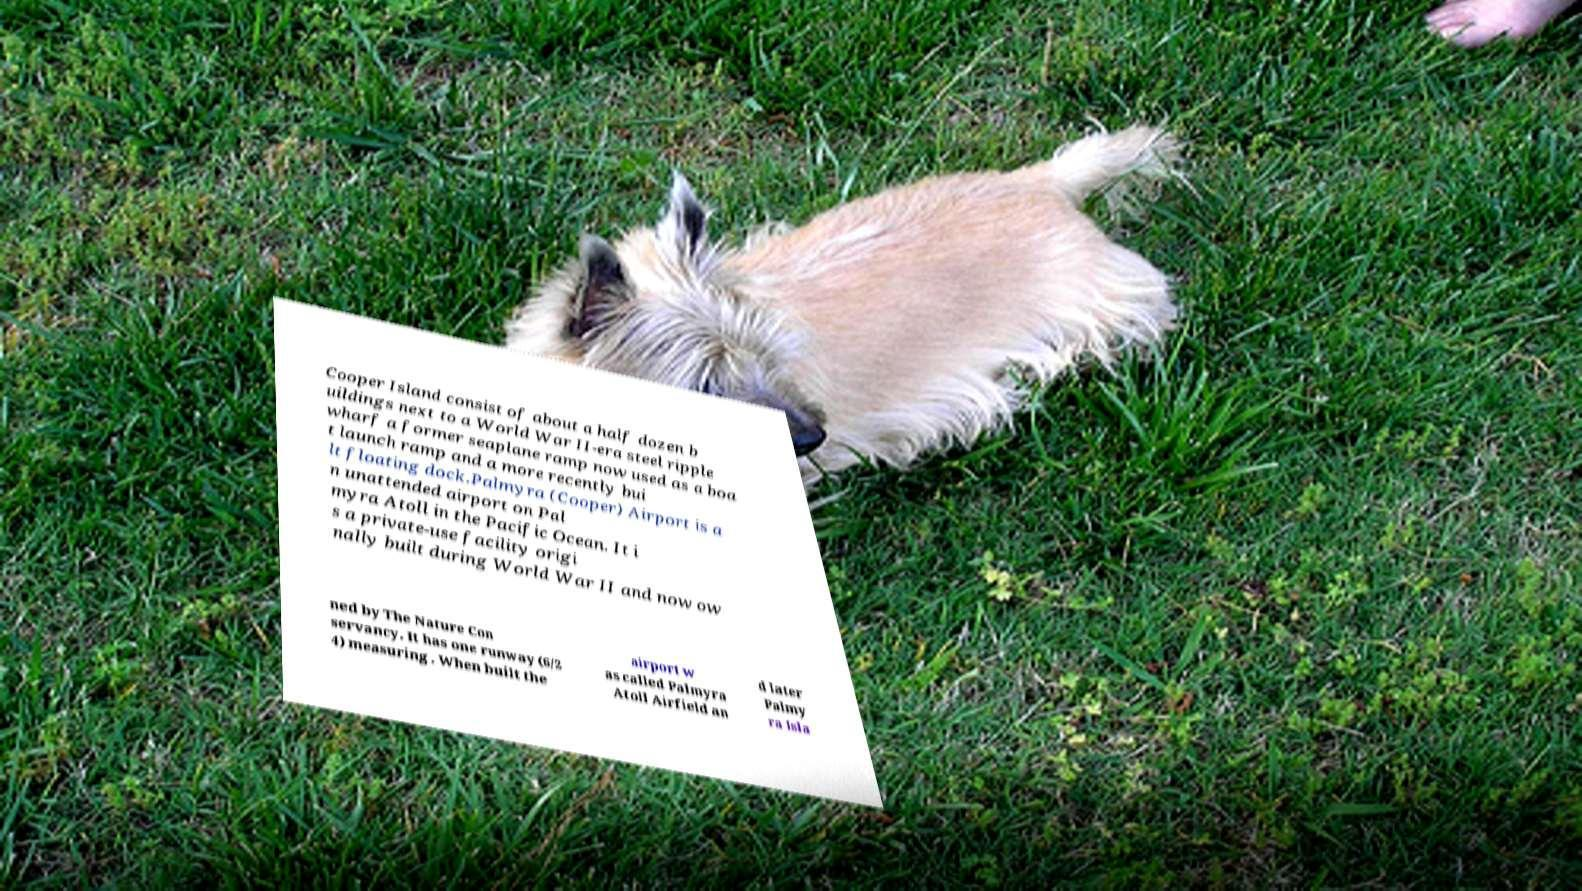Please read and relay the text visible in this image. What does it say? Cooper Island consist of about a half dozen b uildings next to a World War II-era steel ripple wharf a former seaplane ramp now used as a boa t launch ramp and a more recently bui lt floating dock.Palmyra (Cooper) Airport is a n unattended airport on Pal myra Atoll in the Pacific Ocean. It i s a private-use facility origi nally built during World War II and now ow ned by The Nature Con servancy. It has one runway (6/2 4) measuring . When built the airport w as called Palmyra Atoll Airfield an d later Palmy ra Isla 